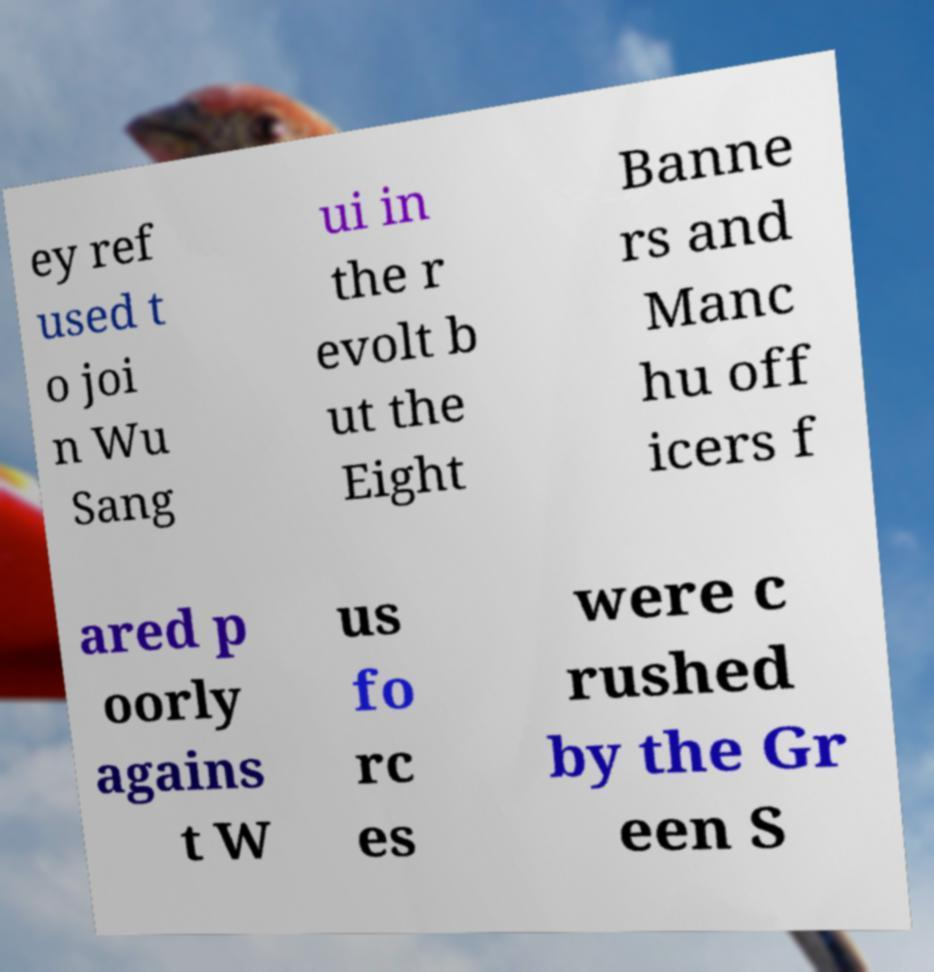What messages or text are displayed in this image? I need them in a readable, typed format. ey ref used t o joi n Wu Sang ui in the r evolt b ut the Eight Banne rs and Manc hu off icers f ared p oorly agains t W us fo rc es were c rushed by the Gr een S 